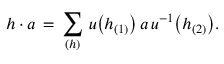Convert formula to latex. <formula><loc_0><loc_0><loc_500><loc_500>h \cdot a \, = \, \sum _ { ( h ) } \, u \left ( h _ { ( 1 ) } \right ) \, a \, u ^ { - 1 } \left ( h _ { ( 2 ) } \right ) .</formula> 